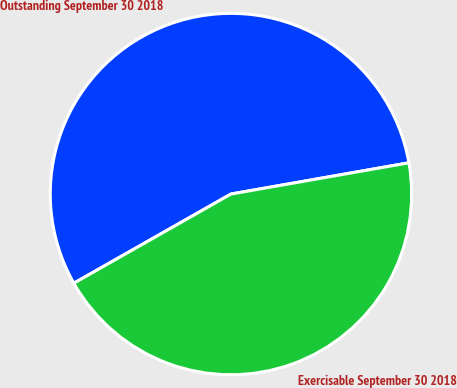Convert chart. <chart><loc_0><loc_0><loc_500><loc_500><pie_chart><fcel>Outstanding September 30 2018<fcel>Exercisable September 30 2018<nl><fcel>55.45%<fcel>44.55%<nl></chart> 